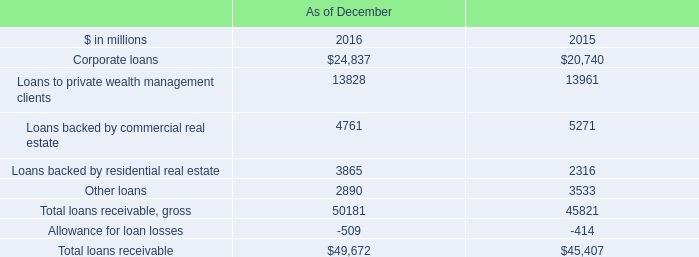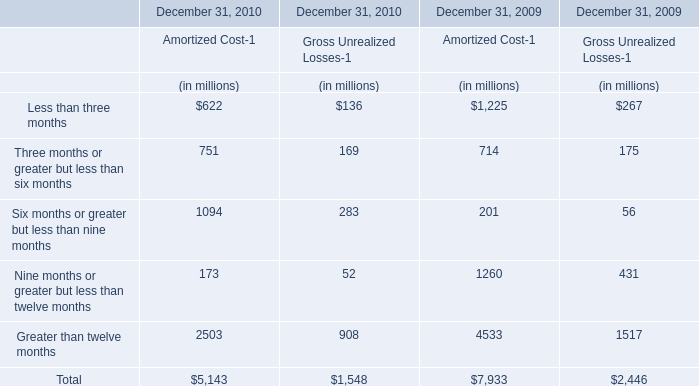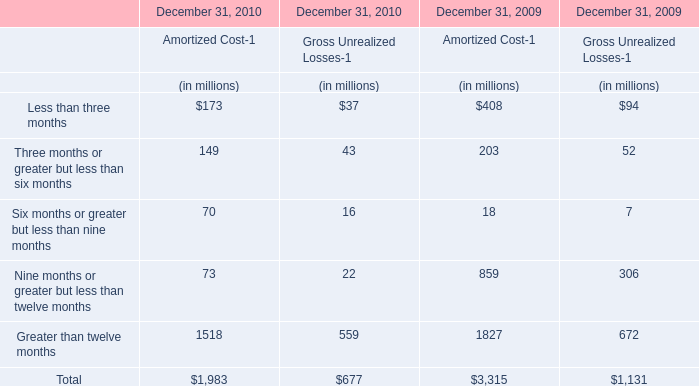What will Less than three months for Gross Unrealized Losses-1 reach in 2011 if it continues to grow at its current rate? (in million) 
Computations: (37 * (1 + ((37 - 94) / 94)))
Answer: 14.56383. 